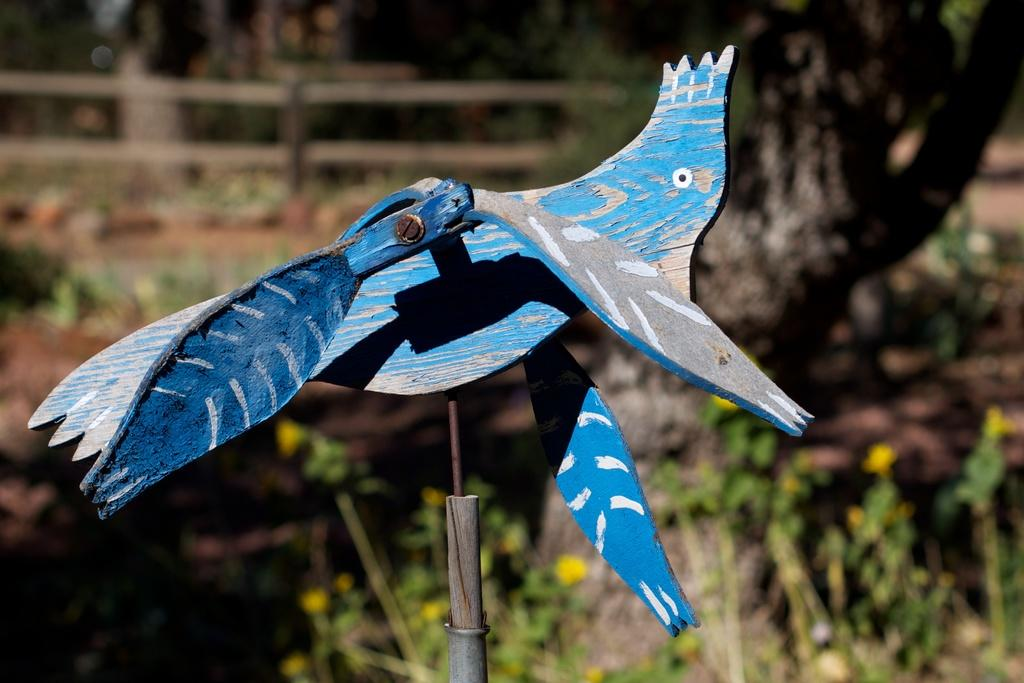What is the main subject in the foreground of the image? There is a wooden bird in the foreground of the image. What can be seen in the background of the image? There are trees and a railing in the background of the image. Is the wooden bird wearing a veil in the image? No, the wooden bird is not wearing a veil in the image. Can you hear a horn in the background of the image? There is no mention of a horn in the image, so it cannot be heard. 